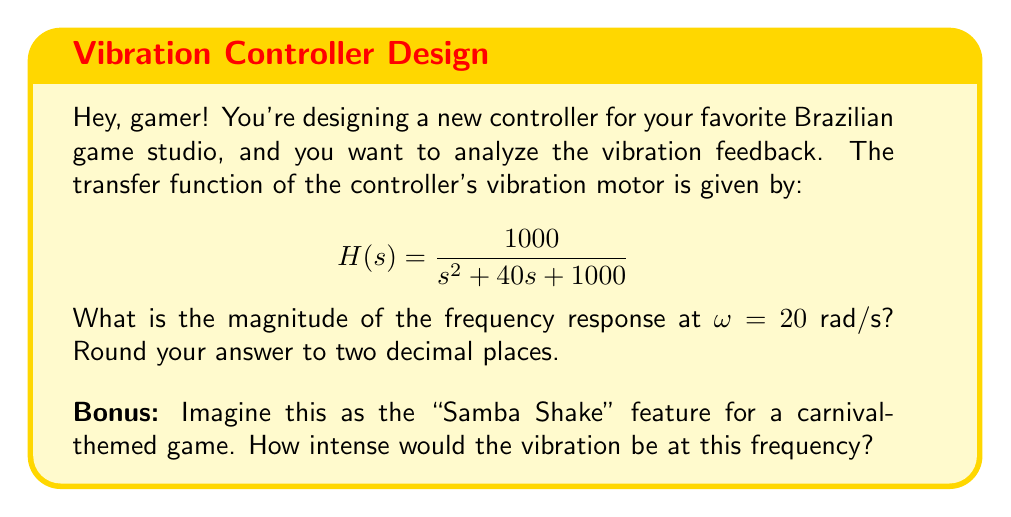Solve this math problem. Alright, let's break this down step-by-step, just like we're planning our next gaming strategy!

1) The frequency response is found by evaluating $H(j\omega)$, where $j$ is the imaginary unit and $\omega$ is the angular frequency.

2) Substitute $s$ with $j\omega$ in the transfer function:

   $$H(j\omega) = \frac{1000}{(j\omega)^2 + 40(j\omega) + 1000}$$

3) For $\omega = 20$ rad/s:

   $$H(j20) = \frac{1000}{(j20)^2 + 40(j20) + 1000}$$

4) Simplify:
   $$H(j20) = \frac{1000}{-400 + 800j + 1000} = \frac{1000}{600 + 800j}$$

5) To find the magnitude, we use:
   $$|H(j\omega)| = \sqrt{\frac{Re^2 + Im^2}{(Re')^2 + (Im')^2}}$$

   Where $Re = 1000$, $Im = 0$, $Re' = 600$, and $Im' = 800$

6) Plug in the values:
   $$|H(j20)| = \sqrt{\frac{1000^2 + 0^2}{600^2 + 800^2}} = \sqrt{\frac{1,000,000}{1,000,000}} = 1$$

7) The magnitude at $\omega = 20$ rad/s is 1.

So, nossa! (Portuguese for "wow!") The "Samba Shake" would be giving a steady vibration at this frequency, perfect for keeping the rhythm in our carnival game!
Answer: $1.00$ 